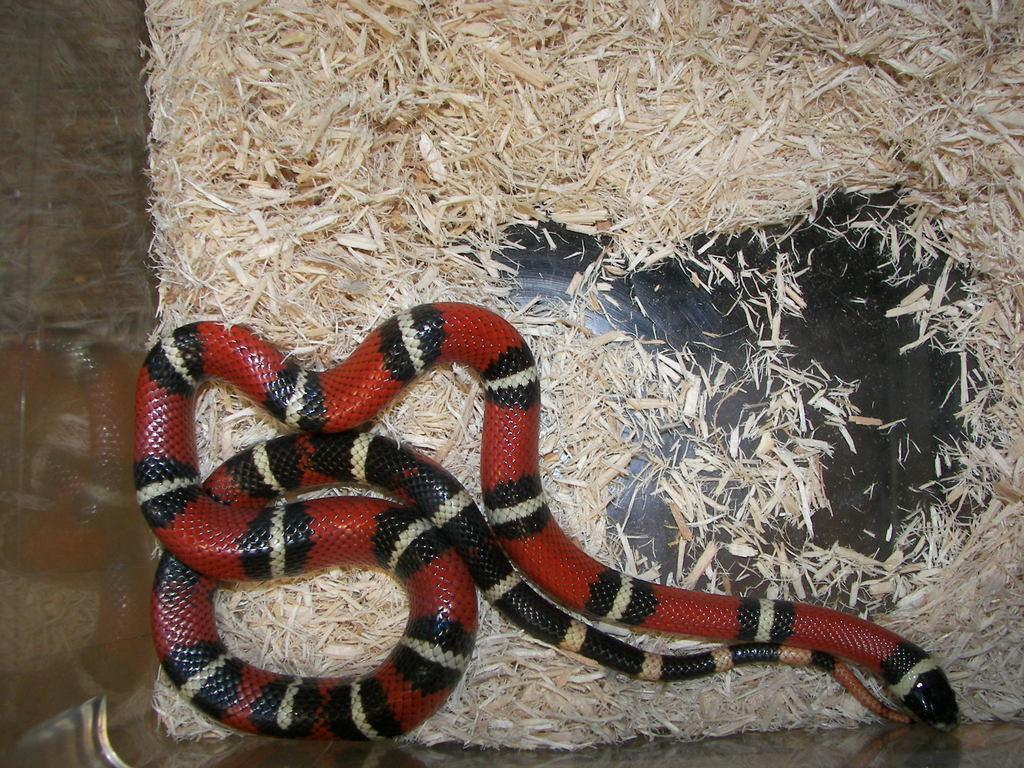What animal is present in the picture? There is a snake in the picture. How is the snake positioned in the image? The snake is cornered to the wall. What colors can be seen on the snake? The snake has red, white, and black colors. What is located under the snake in the image? There is wood scrap under the snake. How many frogs are jumping around the snake in the image? There are no frogs present in the image. What type of building can be seen in the background of the image? There is no building visible in the image; it only features a snake and wood scrap. 